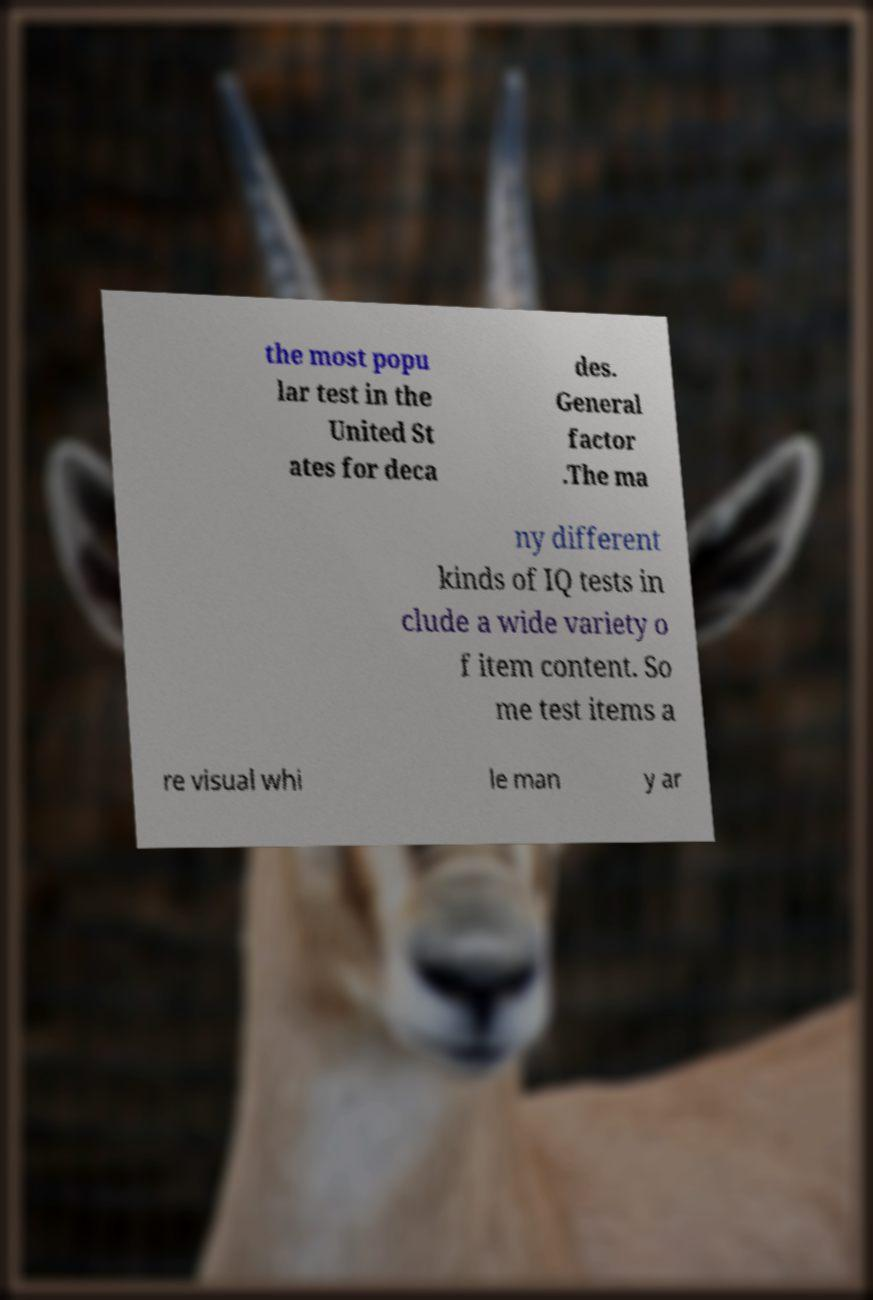Please identify and transcribe the text found in this image. the most popu lar test in the United St ates for deca des. General factor .The ma ny different kinds of IQ tests in clude a wide variety o f item content. So me test items a re visual whi le man y ar 